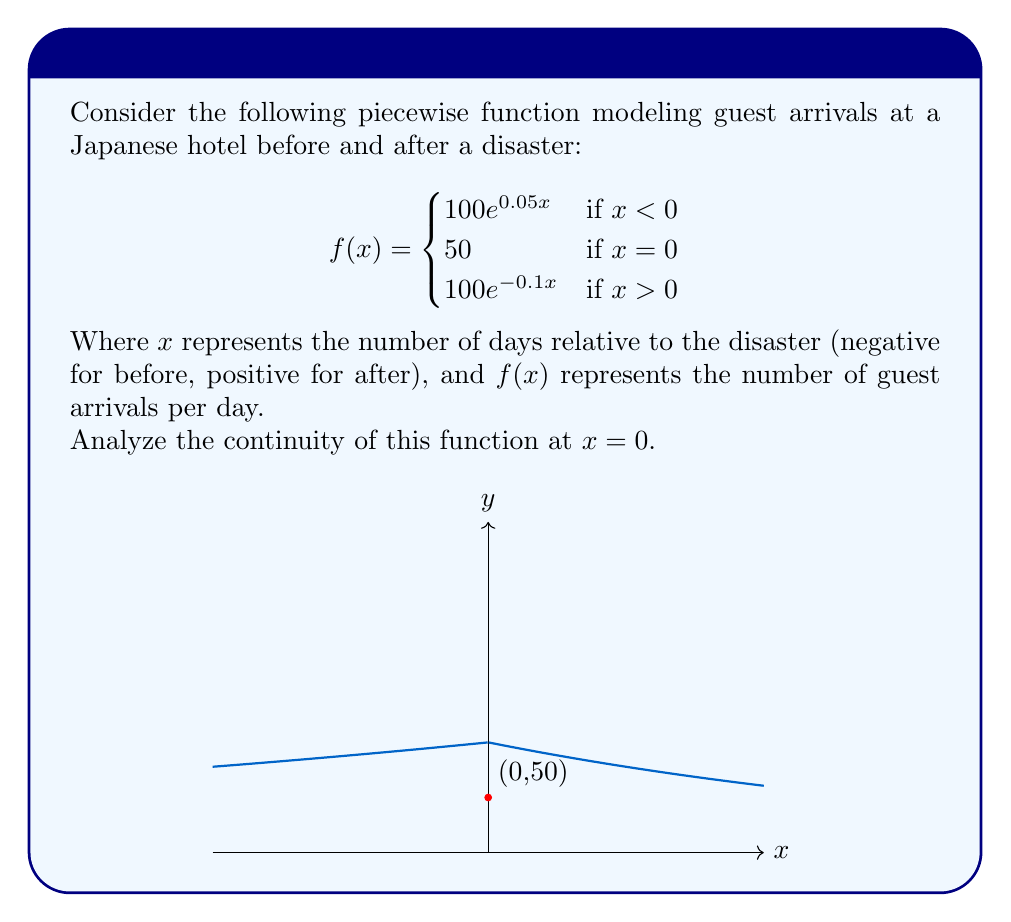Give your solution to this math problem. To analyze the continuity of the function at $x = 0$, we need to check three conditions:

1. $f(0)$ must exist
2. $\lim_{x \to 0^-} f(x)$ must exist
3. $\lim_{x \to 0^+} f(x)$ must exist
4. All three values must be equal

Step 1: Check if $f(0)$ exists
$f(0) = 50$, so it exists.

Step 2: Calculate $\lim_{x \to 0^-} f(x)$
$$\lim_{x \to 0^-} f(x) = \lim_{x \to 0^-} 100e^{0.05x} = 100e^0 = 100$$

Step 3: Calculate $\lim_{x \to 0^+} f(x)$
$$\lim_{x \to 0^+} f(x) = \lim_{x \to 0^+} 100e^{-0.1x} = 100e^0 = 100$$

Step 4: Compare the values
$f(0) = 50$
$\lim_{x \to 0^-} f(x) = 100$
$\lim_{x \to 0^+} f(x) = 100$

Since $f(0) \neq \lim_{x \to 0^-} f(x) = \lim_{x \to 0^+} f(x)$, the function is not continuous at $x = 0$.

The function has a jump discontinuity at $x = 0$, with the function value (50) different from the limit values (100) on both sides.
Answer: The function is discontinuous at $x = 0$ due to a jump discontinuity. 